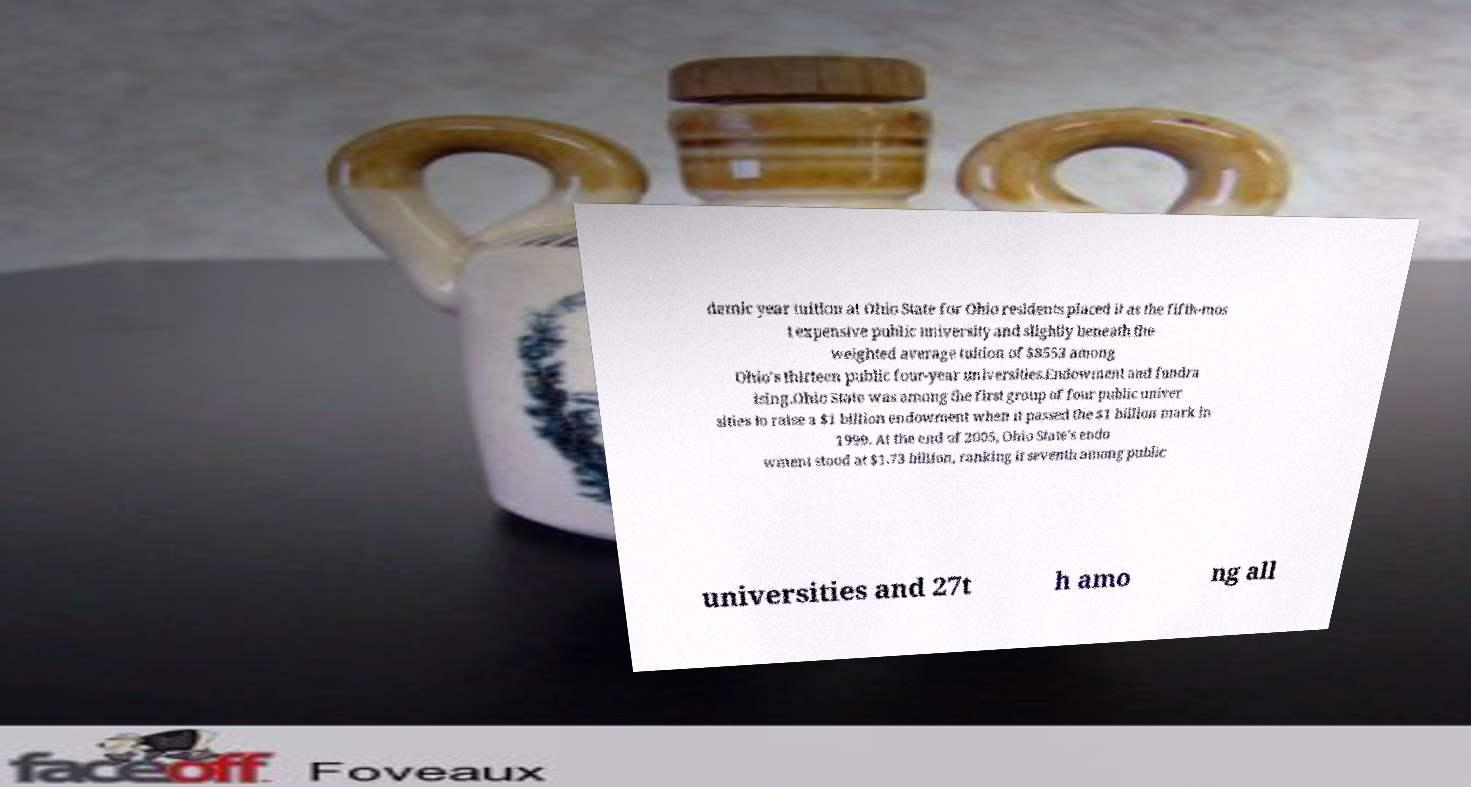I need the written content from this picture converted into text. Can you do that? demic year tuition at Ohio State for Ohio residents placed it as the fifth-mos t expensive public university and slightly beneath the weighted average tuition of $8553 among Ohio's thirteen public four-year universities.Endowment and fundra ising.Ohio State was among the first group of four public univer sities to raise a $1 billion endowment when it passed the $1 billion mark in 1999. At the end of 2005, Ohio State's endo wment stood at $1.73 billion, ranking it seventh among public universities and 27t h amo ng all 